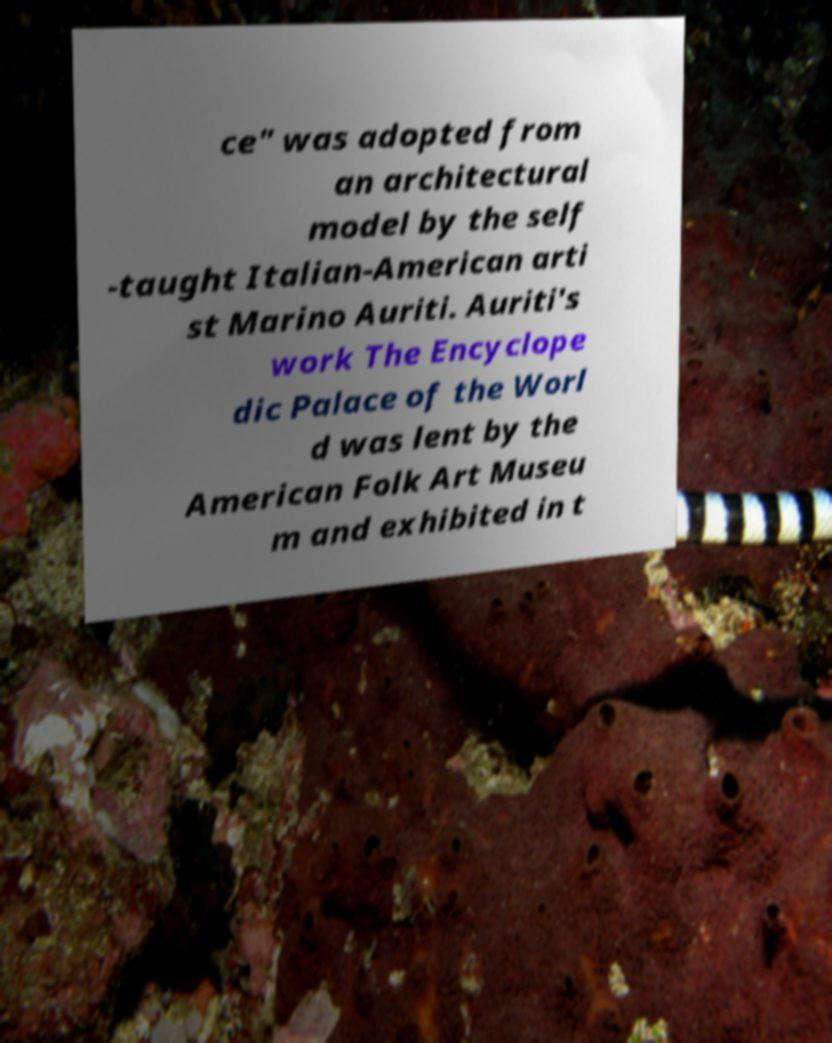Can you read and provide the text displayed in the image?This photo seems to have some interesting text. Can you extract and type it out for me? ce" was adopted from an architectural model by the self -taught Italian-American arti st Marino Auriti. Auriti's work The Encyclope dic Palace of the Worl d was lent by the American Folk Art Museu m and exhibited in t 